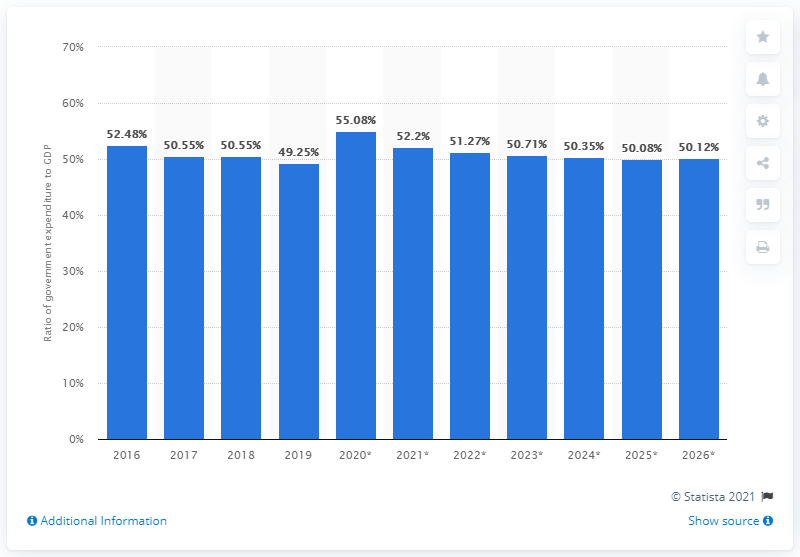Identify some key points in this picture. In 2019, government expenditure in Denmark represented approximately 49.25% of the country's Gross Domestic Product (GDP). 